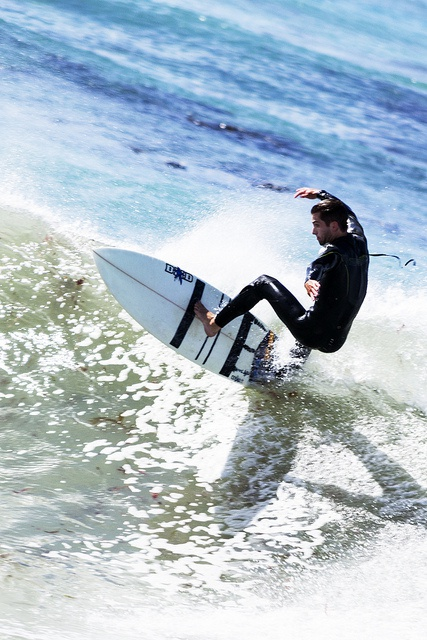Describe the objects in this image and their specific colors. I can see people in lightblue, black, white, gray, and darkgray tones and surfboard in lavender, lightblue, darkgray, black, and gray tones in this image. 